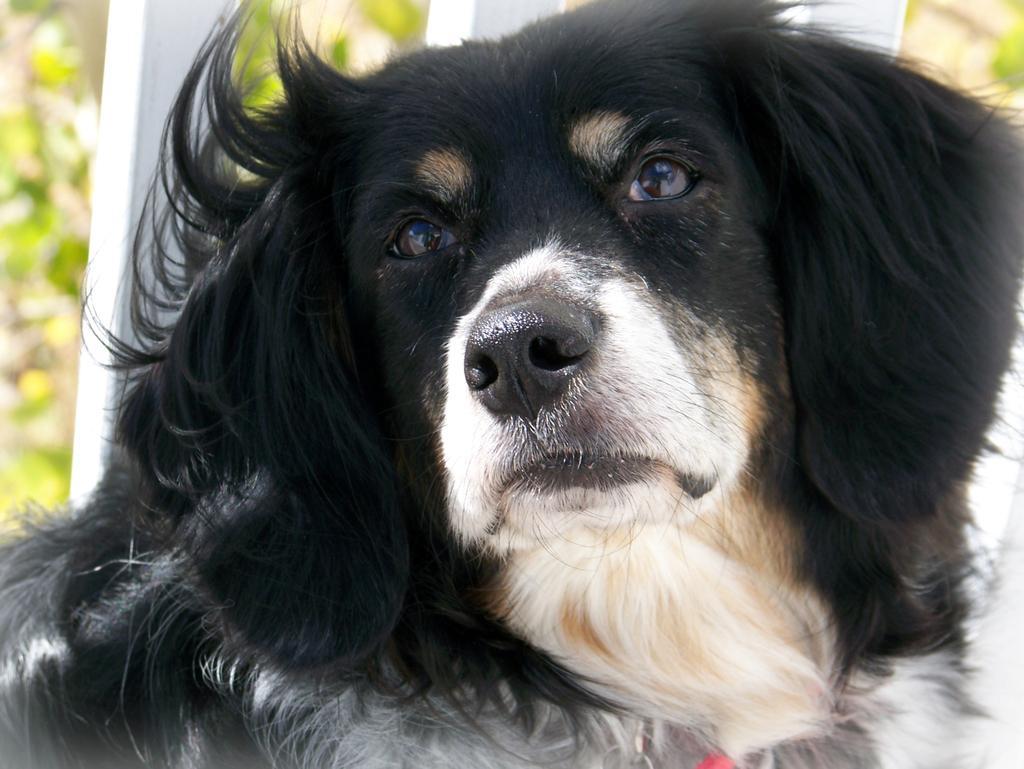In one or two sentences, can you explain what this image depicts? In this image I can see a dog which is white, cream, black and brown in color. In the background I can see few trees and a white colored object. 